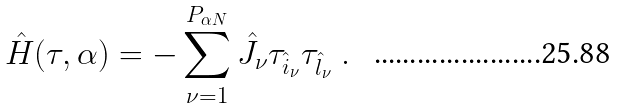<formula> <loc_0><loc_0><loc_500><loc_500>\hat { H } ( \tau , \alpha ) = - \sum _ { \nu = 1 } ^ { P _ { \alpha N } } \hat { J } _ { \nu } \tau _ { \hat { i } _ { \nu } } \tau _ { \hat { l } _ { \nu } } \ .</formula> 